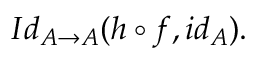Convert formula to latex. <formula><loc_0><loc_0><loc_500><loc_500>I d _ { A \rightarrow A } ( h \circ f , i d _ { A } ) .</formula> 